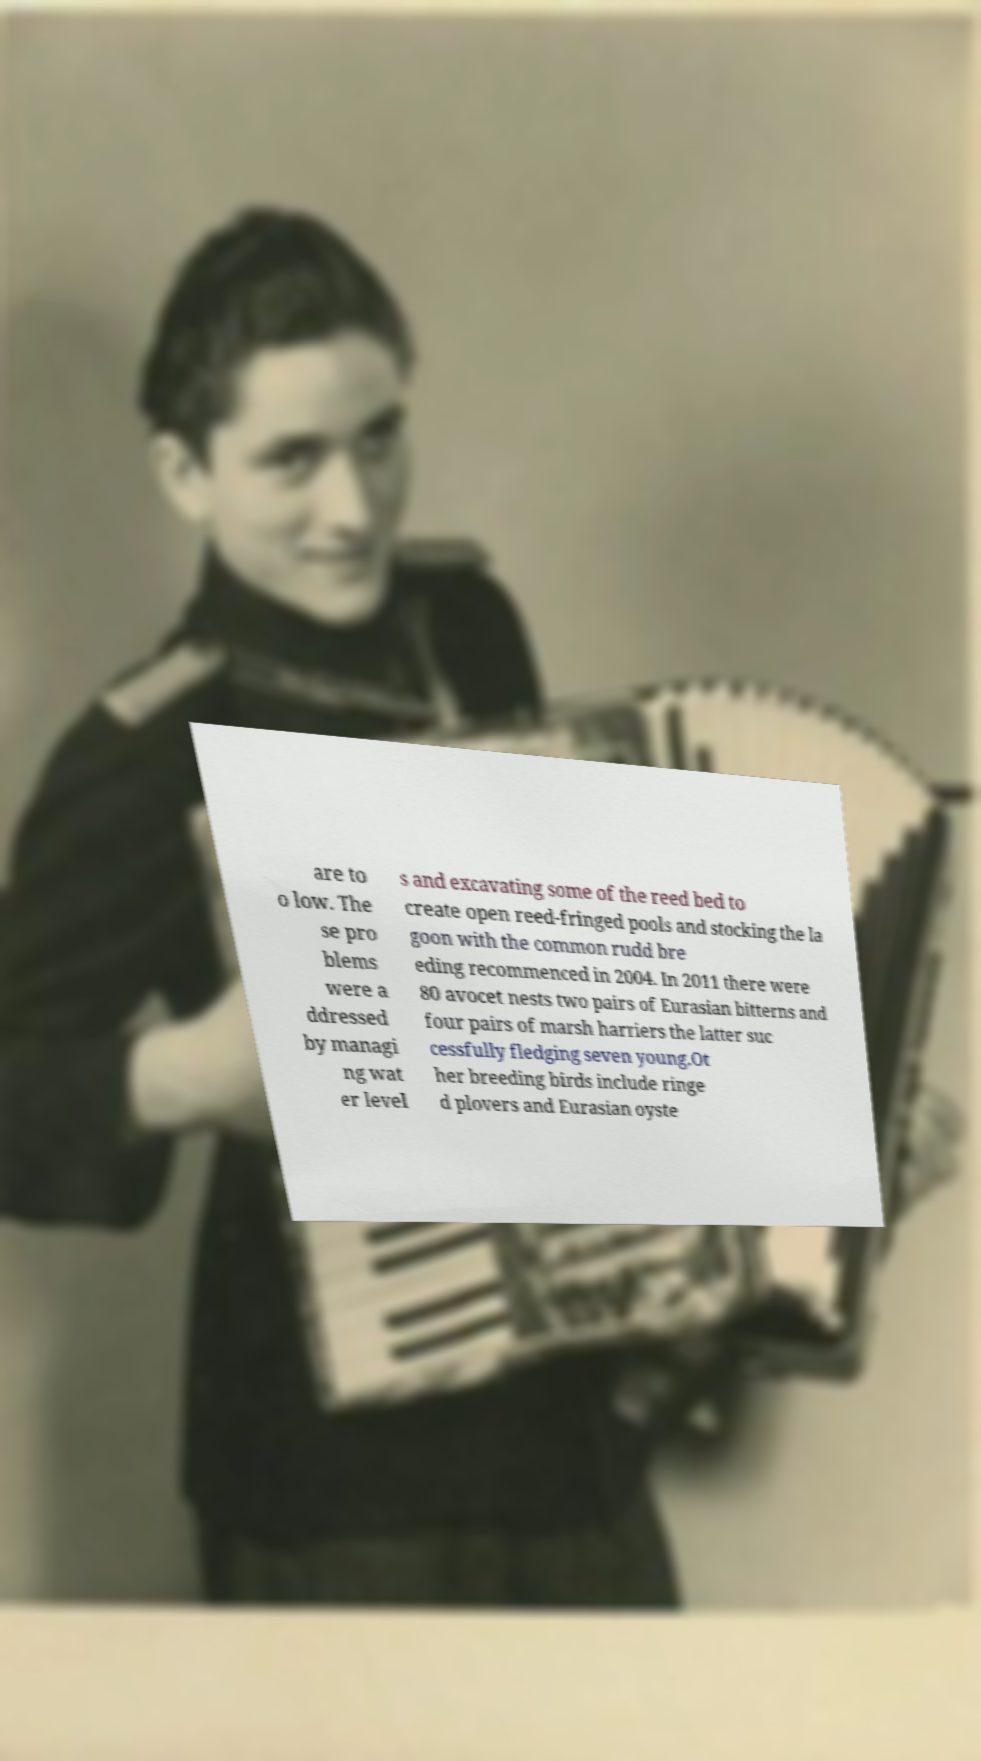Please read and relay the text visible in this image. What does it say? are to o low. The se pro blems were a ddressed by managi ng wat er level s and excavating some of the reed bed to create open reed-fringed pools and stocking the la goon with the common rudd bre eding recommenced in 2004. In 2011 there were 80 avocet nests two pairs of Eurasian bitterns and four pairs of marsh harriers the latter suc cessfully fledging seven young.Ot her breeding birds include ringe d plovers and Eurasian oyste 